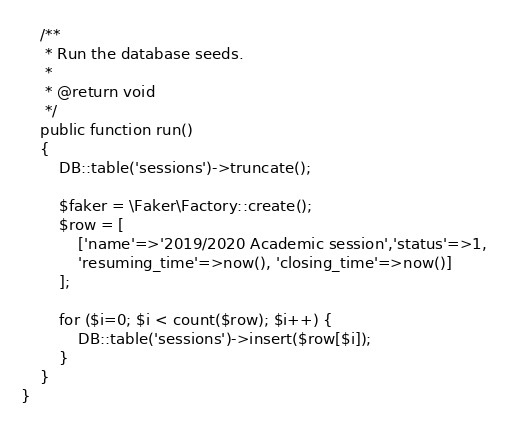Convert code to text. <code><loc_0><loc_0><loc_500><loc_500><_PHP_>    /**
     * Run the database seeds.
     *
     * @return void
     */
    public function run()
    {
        DB::table('sessions')->truncate();

        $faker = \Faker\Factory::create();
        $row = [
            ['name'=>'2019/2020 Academic session','status'=>1, 
            'resuming_time'=>now(),	'closing_time'=>now()]
        ];

        for ($i=0; $i < count($row); $i++) { 
            DB::table('sessions')->insert($row[$i]);
        }     
    }
}
</code> 